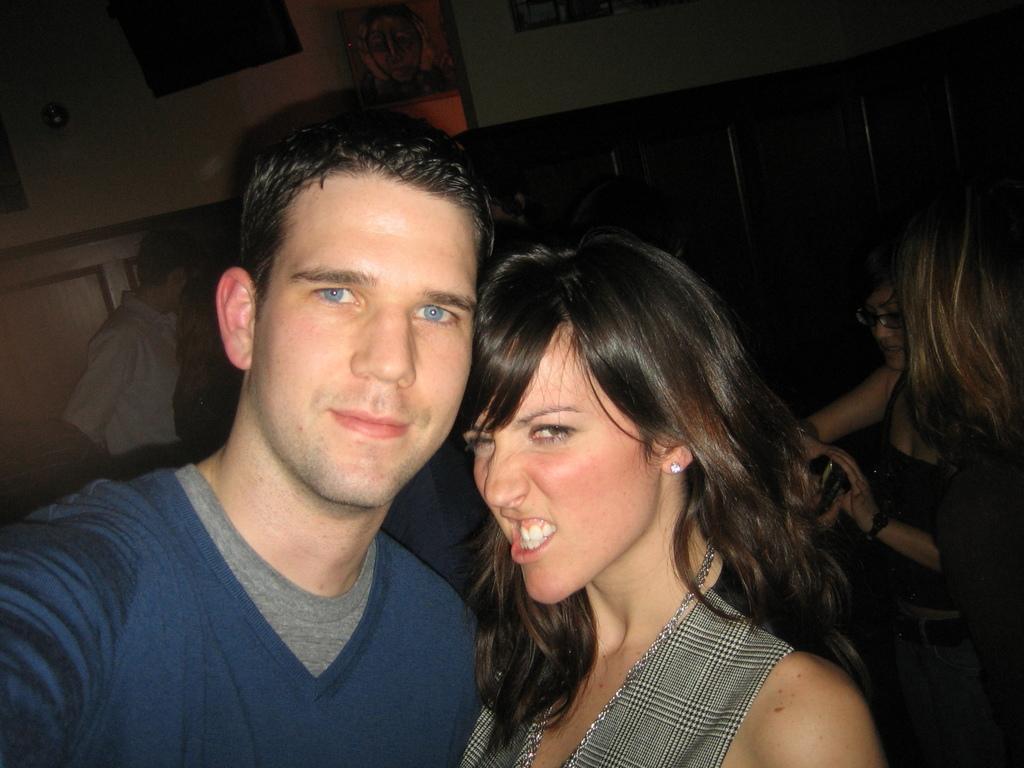How would you summarize this image in a sentence or two? In this image I can see the group of people with different color dresses. In the background I can see the boards to the wall. 